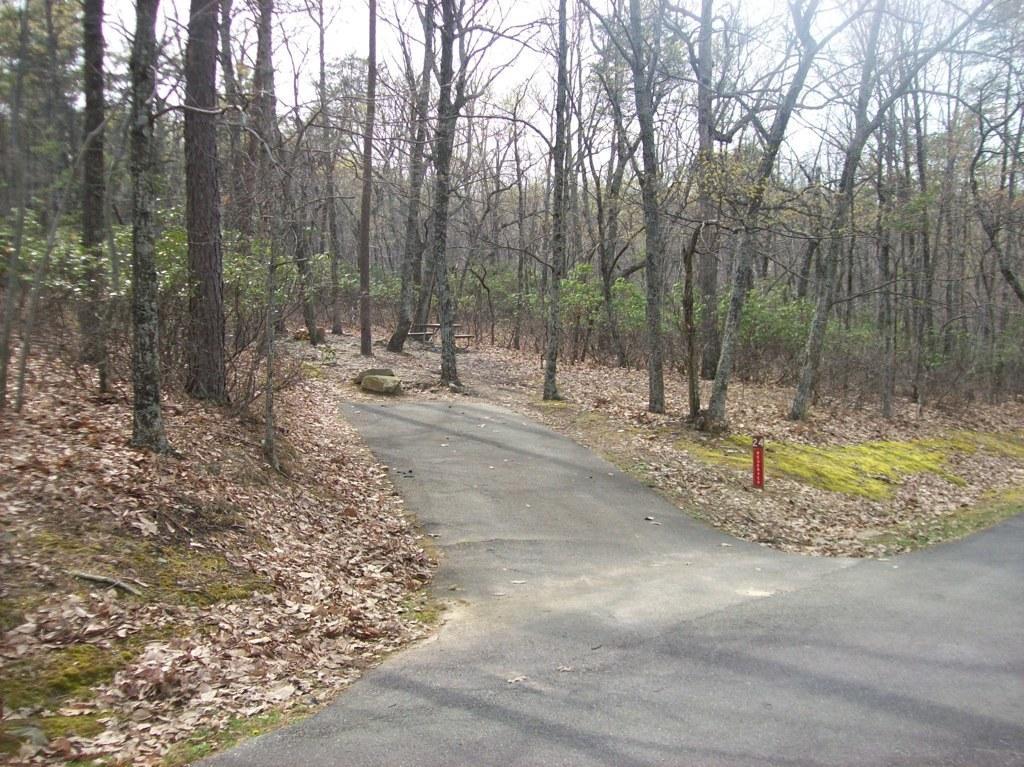Can you describe this image briefly? In this picture we can see trees,road and we can see sky in the background. 